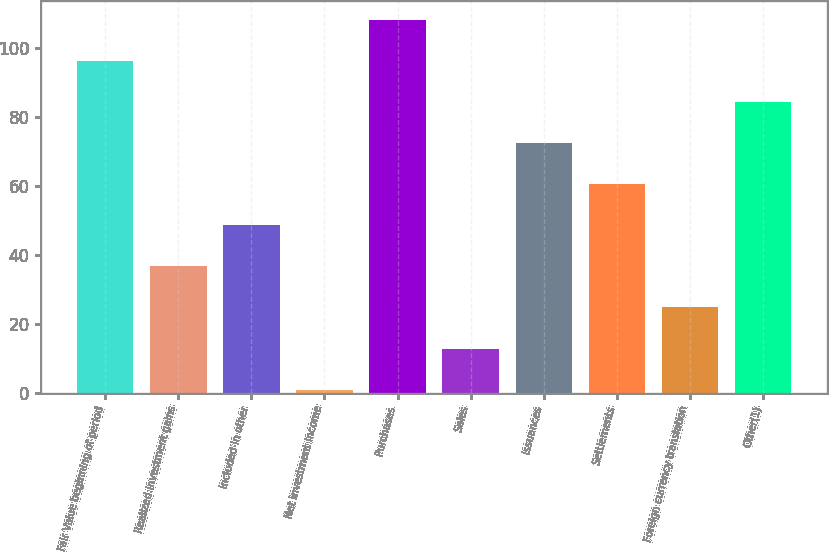<chart> <loc_0><loc_0><loc_500><loc_500><bar_chart><fcel>Fair Value beginning of period<fcel>Realized investment gains<fcel>Included in other<fcel>Net investment income<fcel>Purchases<fcel>Sales<fcel>Issuances<fcel>Settlements<fcel>Foreign currency translation<fcel>Other(1)<nl><fcel>96.19<fcel>36.67<fcel>48.58<fcel>0.95<fcel>108.09<fcel>12.86<fcel>72.38<fcel>60.48<fcel>24.77<fcel>84.28<nl></chart> 